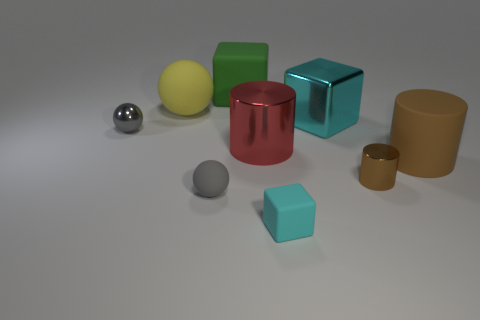Is the color of the tiny matte sphere the same as the small sphere that is behind the small brown metallic thing? Yes, the small matte sphere indeed appears to share the same grayscale tone as the tiny sphere that is situated behind the object with a brown metallic finish. 